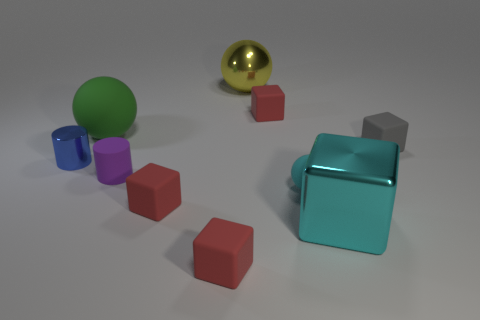There is a tiny matte ball; is it the same color as the big metallic thing that is in front of the small cyan matte thing?
Provide a short and direct response. Yes. Is there a cube of the same color as the tiny sphere?
Make the answer very short. Yes. Is the shiny block the same color as the small ball?
Offer a very short reply. Yes. There is a big metal object that is the same color as the tiny matte sphere; what shape is it?
Ensure brevity in your answer.  Cube. Are there any objects in front of the rubber sphere to the left of the matte cylinder?
Provide a short and direct response. Yes. The small cyan thing that is the same material as the gray cube is what shape?
Your answer should be compact. Sphere. What is the material of the other thing that is the same shape as the blue metal object?
Offer a very short reply. Rubber. What number of other things are the same size as the cyan metal object?
Your answer should be compact. 2. There is a sphere that is the same color as the big shiny cube; what is its size?
Offer a terse response. Small. There is a metal object that is behind the big matte sphere; does it have the same shape as the tiny cyan thing?
Make the answer very short. Yes. 